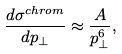Convert formula to latex. <formula><loc_0><loc_0><loc_500><loc_500>\frac { d \sigma ^ { c h r o m } } { d p _ { \bot } } \approx \frac { A } { p _ { \bot } ^ { 6 } } ,</formula> 